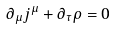Convert formula to latex. <formula><loc_0><loc_0><loc_500><loc_500>\partial _ { \mu } j ^ { \mu } + \partial _ { \tau } \rho = 0</formula> 